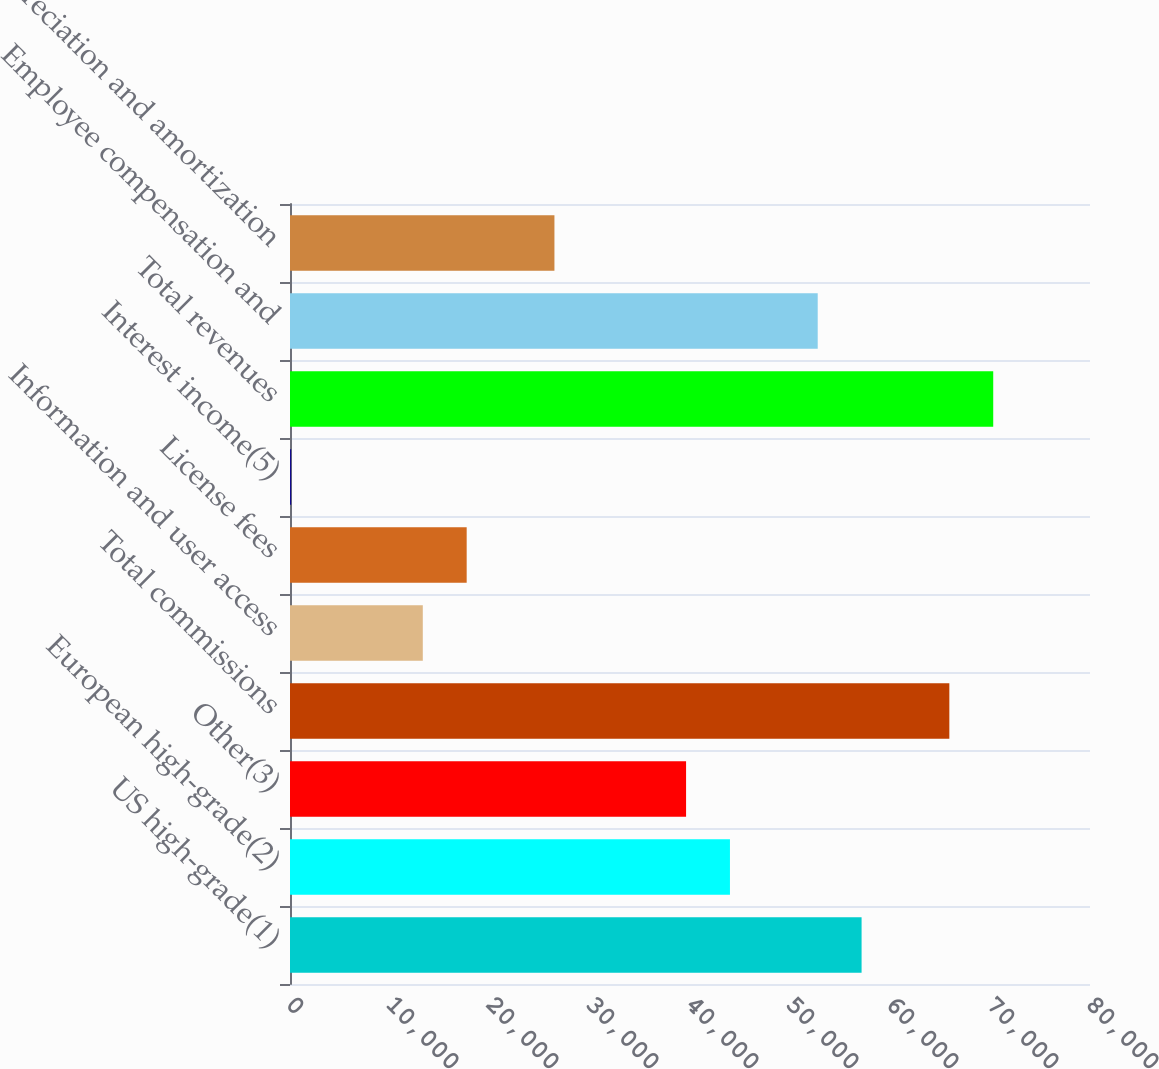<chart> <loc_0><loc_0><loc_500><loc_500><bar_chart><fcel>US high-grade(1)<fcel>European high-grade(2)<fcel>Other(3)<fcel>Total commissions<fcel>Information and user access<fcel>License fees<fcel>Interest income(5)<fcel>Total revenues<fcel>Employee compensation and<fcel>Depreciation and amortization<nl><fcel>57158.7<fcel>43995<fcel>39607.1<fcel>65934.5<fcel>13279.7<fcel>17667.6<fcel>116<fcel>70322.4<fcel>52770.8<fcel>26443.4<nl></chart> 